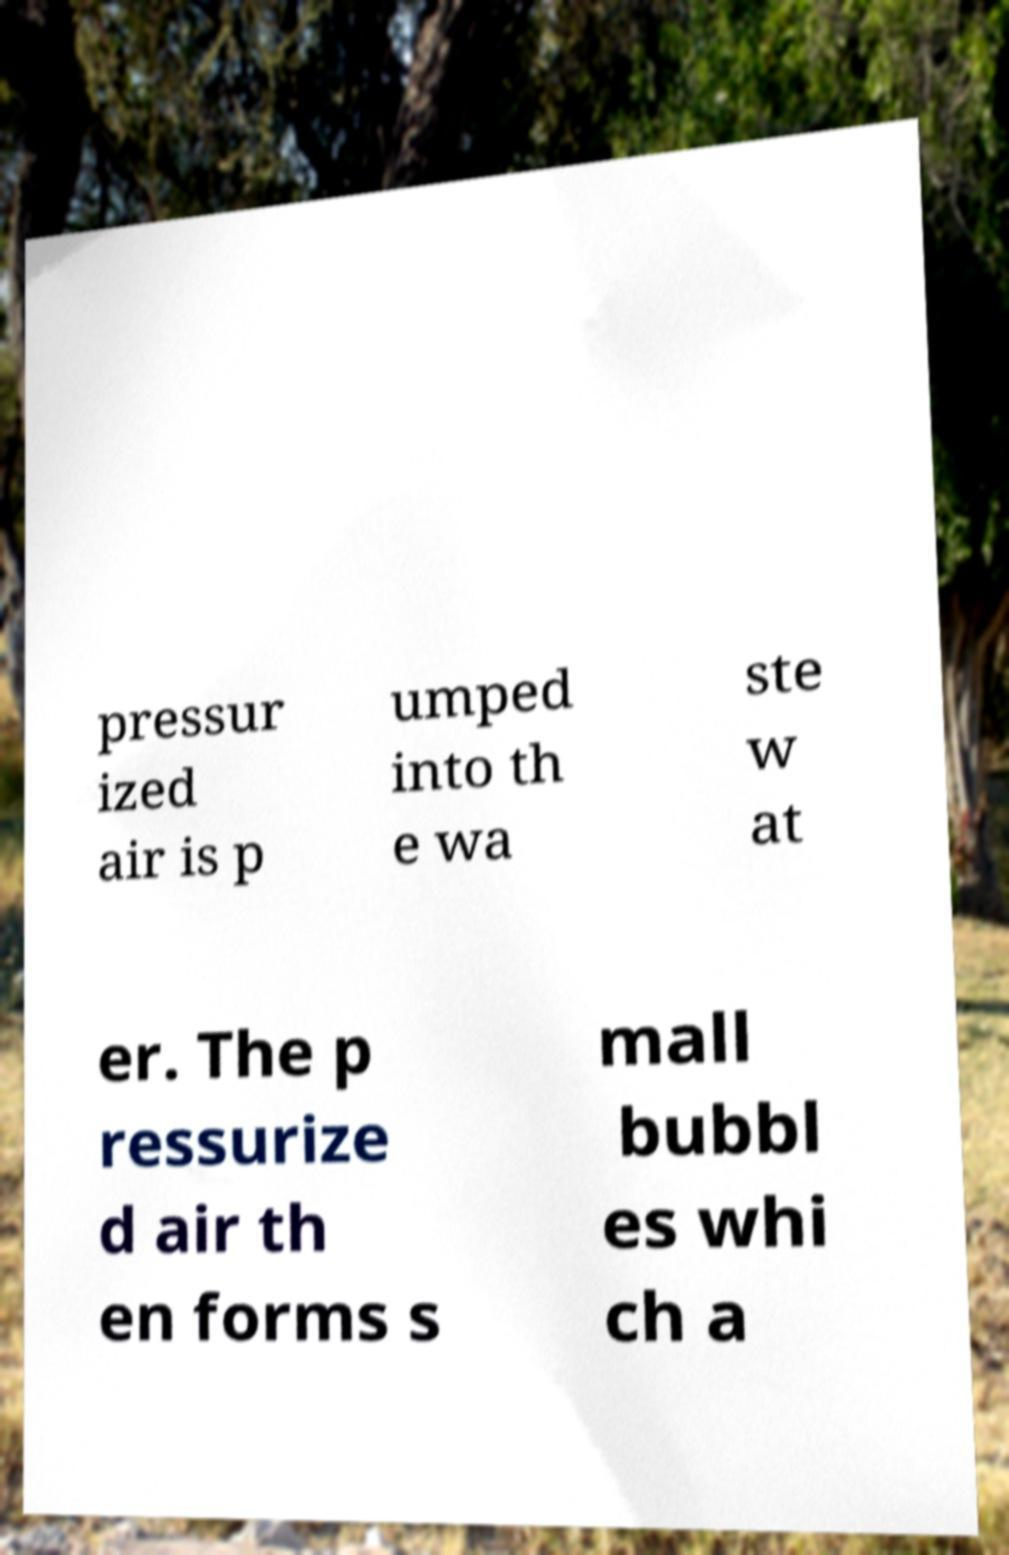Could you assist in decoding the text presented in this image and type it out clearly? pressur ized air is p umped into th e wa ste w at er. The p ressurize d air th en forms s mall bubbl es whi ch a 